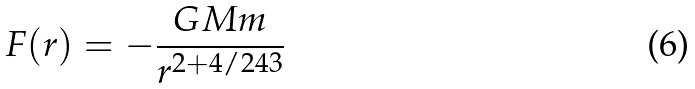<formula> <loc_0><loc_0><loc_500><loc_500>F ( r ) = - \frac { G M m } { r ^ { 2 + 4 / 2 4 3 } }</formula> 